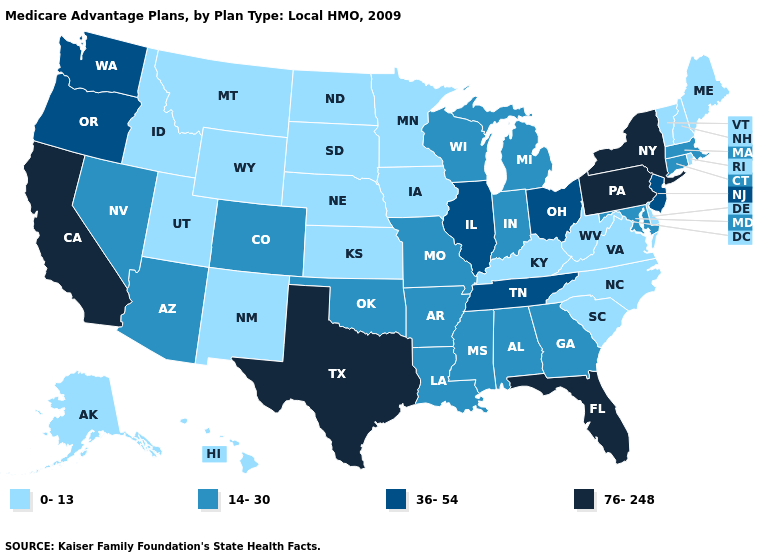What is the lowest value in the MidWest?
Be succinct. 0-13. What is the value of Mississippi?
Keep it brief. 14-30. Among the states that border Arkansas , does Texas have the highest value?
Write a very short answer. Yes. What is the highest value in the West ?
Short answer required. 76-248. What is the highest value in the Northeast ?
Write a very short answer. 76-248. What is the value of South Carolina?
Keep it brief. 0-13. Does Colorado have the lowest value in the USA?
Concise answer only. No. Which states hav the highest value in the MidWest?
Quick response, please. Illinois, Ohio. Does the first symbol in the legend represent the smallest category?
Give a very brief answer. Yes. What is the highest value in states that border North Carolina?
Answer briefly. 36-54. What is the value of Pennsylvania?
Give a very brief answer. 76-248. What is the lowest value in the USA?
Keep it brief. 0-13. Does New Jersey have a lower value than Illinois?
Concise answer only. No. Among the states that border Rhode Island , which have the highest value?
Keep it brief. Connecticut, Massachusetts. 